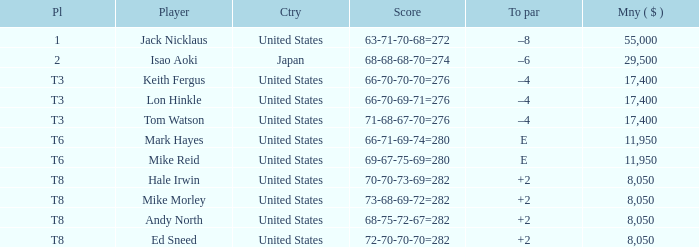What country has the score og 66-70-69-71=276? United States. 